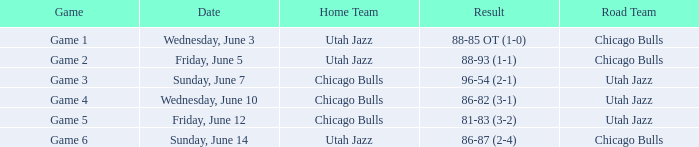Home Team of chicago bulls, and a Result of 81-83 (3-2) involved what game? Game 5. Can you parse all the data within this table? {'header': ['Game', 'Date', 'Home Team', 'Result', 'Road Team'], 'rows': [['Game 1', 'Wednesday, June 3', 'Utah Jazz', '88-85 OT (1-0)', 'Chicago Bulls'], ['Game 2', 'Friday, June 5', 'Utah Jazz', '88-93 (1-1)', 'Chicago Bulls'], ['Game 3', 'Sunday, June 7', 'Chicago Bulls', '96-54 (2-1)', 'Utah Jazz'], ['Game 4', 'Wednesday, June 10', 'Chicago Bulls', '86-82 (3-1)', 'Utah Jazz'], ['Game 5', 'Friday, June 12', 'Chicago Bulls', '81-83 (3-2)', 'Utah Jazz'], ['Game 6', 'Sunday, June 14', 'Utah Jazz', '86-87 (2-4)', 'Chicago Bulls']]} 